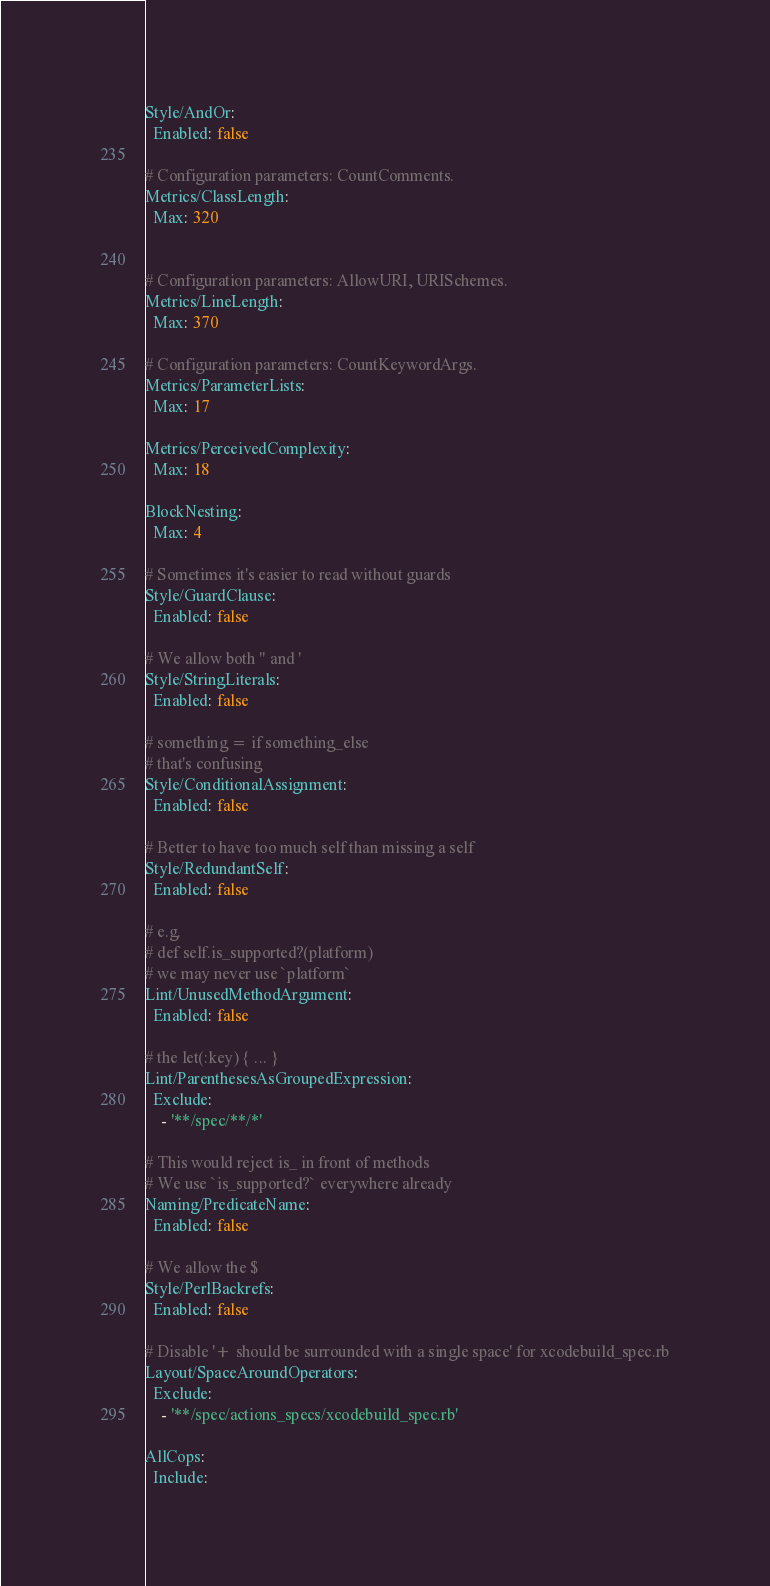<code> <loc_0><loc_0><loc_500><loc_500><_YAML_>Style/AndOr:
  Enabled: false

# Configuration parameters: CountComments.
Metrics/ClassLength:
  Max: 320


# Configuration parameters: AllowURI, URISchemes.
Metrics/LineLength:
  Max: 370

# Configuration parameters: CountKeywordArgs.
Metrics/ParameterLists:
  Max: 17

Metrics/PerceivedComplexity:
  Max: 18

BlockNesting:
  Max: 4

# Sometimes it's easier to read without guards
Style/GuardClause:
  Enabled: false

# We allow both " and '
Style/StringLiterals:
  Enabled: false

# something = if something_else
# that's confusing
Style/ConditionalAssignment:
  Enabled: false

# Better to have too much self than missing a self
Style/RedundantSelf:
  Enabled: false

# e.g.
# def self.is_supported?(platform)
# we may never use `platform`
Lint/UnusedMethodArgument:
  Enabled: false

# the let(:key) { ... }
Lint/ParenthesesAsGroupedExpression:
  Exclude:
    - '**/spec/**/*'

# This would reject is_ in front of methods
# We use `is_supported?` everywhere already
Naming/PredicateName:
  Enabled: false

# We allow the $
Style/PerlBackrefs:
  Enabled: false

# Disable '+ should be surrounded with a single space' for xcodebuild_spec.rb
Layout/SpaceAroundOperators:
  Exclude:
    - '**/spec/actions_specs/xcodebuild_spec.rb'

AllCops:
  Include:</code> 